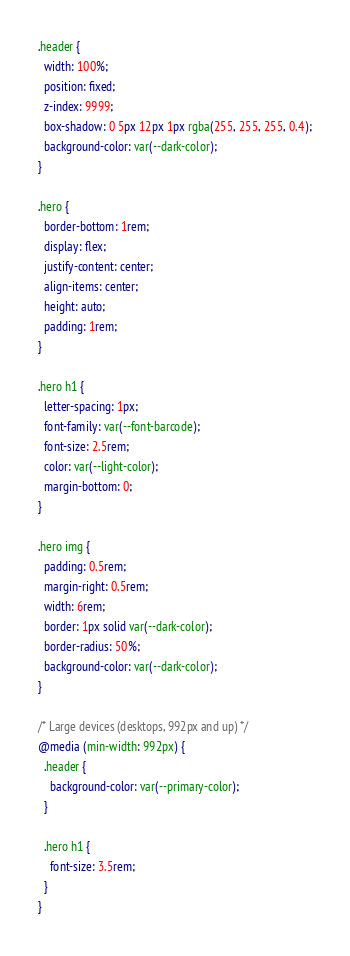<code> <loc_0><loc_0><loc_500><loc_500><_CSS_>.header {
  width: 100%;
  position: fixed;
  z-index: 9999;
  box-shadow: 0 5px 12px 1px rgba(255, 255, 255, 0.4);
  background-color: var(--dark-color);
}

.hero {
  border-bottom: 1rem;
  display: flex;
  justify-content: center;
  align-items: center;
  height: auto;
  padding: 1rem;
}

.hero h1 {
  letter-spacing: 1px;
  font-family: var(--font-barcode);
  font-size: 2.5rem;
  color: var(--light-color);
  margin-bottom: 0;
}

.hero img {
  padding: 0.5rem;
  margin-right: 0.5rem;
  width: 6rem;
  border: 1px solid var(--dark-color);
  border-radius: 50%;
  background-color: var(--dark-color);
}

/* Large devices (desktops, 992px and up) */
@media (min-width: 992px) {
  .header {
    background-color: var(--primary-color);
  }

  .hero h1 {
    font-size: 3.5rem;
  }
}
</code> 